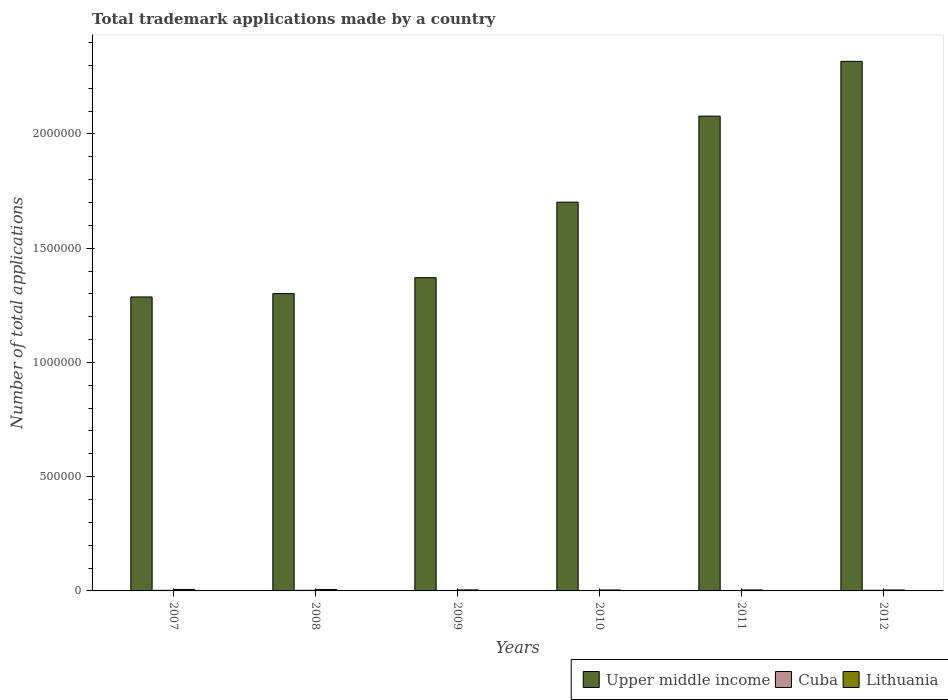How many different coloured bars are there?
Keep it short and to the point. 3. How many groups of bars are there?
Ensure brevity in your answer.  6. Are the number of bars on each tick of the X-axis equal?
Make the answer very short. Yes. In how many cases, is the number of bars for a given year not equal to the number of legend labels?
Keep it short and to the point. 0. What is the number of applications made by in Upper middle income in 2008?
Offer a very short reply. 1.30e+06. Across all years, what is the maximum number of applications made by in Lithuania?
Make the answer very short. 6440. Across all years, what is the minimum number of applications made by in Cuba?
Offer a terse response. 1389. In which year was the number of applications made by in Lithuania maximum?
Give a very brief answer. 2007. What is the total number of applications made by in Cuba in the graph?
Offer a very short reply. 1.32e+04. What is the difference between the number of applications made by in Lithuania in 2008 and that in 2012?
Provide a succinct answer. 2110. What is the difference between the number of applications made by in Upper middle income in 2007 and the number of applications made by in Cuba in 2008?
Offer a terse response. 1.28e+06. What is the average number of applications made by in Lithuania per year?
Provide a succinct answer. 5008. In the year 2010, what is the difference between the number of applications made by in Lithuania and number of applications made by in Upper middle income?
Ensure brevity in your answer.  -1.70e+06. In how many years, is the number of applications made by in Lithuania greater than 100000?
Your response must be concise. 0. What is the ratio of the number of applications made by in Lithuania in 2011 to that in 2012?
Make the answer very short. 1.02. Is the number of applications made by in Cuba in 2008 less than that in 2012?
Your response must be concise. Yes. Is the difference between the number of applications made by in Lithuania in 2008 and 2011 greater than the difference between the number of applications made by in Upper middle income in 2008 and 2011?
Provide a short and direct response. Yes. What is the difference between the highest and the second highest number of applications made by in Cuba?
Offer a terse response. 199. What is the difference between the highest and the lowest number of applications made by in Lithuania?
Offer a very short reply. 2218. In how many years, is the number of applications made by in Upper middle income greater than the average number of applications made by in Upper middle income taken over all years?
Provide a succinct answer. 3. What does the 3rd bar from the left in 2009 represents?
Ensure brevity in your answer.  Lithuania. What does the 1st bar from the right in 2007 represents?
Make the answer very short. Lithuania. How many bars are there?
Offer a terse response. 18. Are all the bars in the graph horizontal?
Offer a very short reply. No. What is the difference between two consecutive major ticks on the Y-axis?
Keep it short and to the point. 5.00e+05. Are the values on the major ticks of Y-axis written in scientific E-notation?
Ensure brevity in your answer.  No. Does the graph contain grids?
Make the answer very short. No. How many legend labels are there?
Your answer should be very brief. 3. How are the legend labels stacked?
Ensure brevity in your answer.  Horizontal. What is the title of the graph?
Give a very brief answer. Total trademark applications made by a country. What is the label or title of the X-axis?
Make the answer very short. Years. What is the label or title of the Y-axis?
Offer a terse response. Number of total applications. What is the Number of total applications of Upper middle income in 2007?
Provide a short and direct response. 1.29e+06. What is the Number of total applications in Cuba in 2007?
Ensure brevity in your answer.  2407. What is the Number of total applications of Lithuania in 2007?
Your answer should be very brief. 6440. What is the Number of total applications in Upper middle income in 2008?
Your answer should be very brief. 1.30e+06. What is the Number of total applications in Cuba in 2008?
Your response must be concise. 2540. What is the Number of total applications in Lithuania in 2008?
Your answer should be compact. 6332. What is the Number of total applications in Upper middle income in 2009?
Give a very brief answer. 1.37e+06. What is the Number of total applications in Cuba in 2009?
Keep it short and to the point. 2042. What is the Number of total applications in Lithuania in 2009?
Your response must be concise. 4465. What is the Number of total applications of Upper middle income in 2010?
Offer a terse response. 1.70e+06. What is the Number of total applications in Cuba in 2010?
Keep it short and to the point. 1389. What is the Number of total applications in Lithuania in 2010?
Your response must be concise. 4274. What is the Number of total applications of Upper middle income in 2011?
Provide a succinct answer. 2.08e+06. What is the Number of total applications in Cuba in 2011?
Give a very brief answer. 2041. What is the Number of total applications of Lithuania in 2011?
Your answer should be compact. 4315. What is the Number of total applications of Upper middle income in 2012?
Your answer should be compact. 2.32e+06. What is the Number of total applications in Cuba in 2012?
Keep it short and to the point. 2739. What is the Number of total applications of Lithuania in 2012?
Keep it short and to the point. 4222. Across all years, what is the maximum Number of total applications of Upper middle income?
Offer a terse response. 2.32e+06. Across all years, what is the maximum Number of total applications in Cuba?
Provide a short and direct response. 2739. Across all years, what is the maximum Number of total applications in Lithuania?
Your answer should be very brief. 6440. Across all years, what is the minimum Number of total applications of Upper middle income?
Ensure brevity in your answer.  1.29e+06. Across all years, what is the minimum Number of total applications in Cuba?
Provide a short and direct response. 1389. Across all years, what is the minimum Number of total applications of Lithuania?
Keep it short and to the point. 4222. What is the total Number of total applications in Upper middle income in the graph?
Your response must be concise. 1.01e+07. What is the total Number of total applications of Cuba in the graph?
Ensure brevity in your answer.  1.32e+04. What is the total Number of total applications in Lithuania in the graph?
Offer a very short reply. 3.00e+04. What is the difference between the Number of total applications in Upper middle income in 2007 and that in 2008?
Make the answer very short. -1.46e+04. What is the difference between the Number of total applications in Cuba in 2007 and that in 2008?
Provide a succinct answer. -133. What is the difference between the Number of total applications of Lithuania in 2007 and that in 2008?
Provide a short and direct response. 108. What is the difference between the Number of total applications of Upper middle income in 2007 and that in 2009?
Provide a succinct answer. -8.44e+04. What is the difference between the Number of total applications of Cuba in 2007 and that in 2009?
Ensure brevity in your answer.  365. What is the difference between the Number of total applications in Lithuania in 2007 and that in 2009?
Give a very brief answer. 1975. What is the difference between the Number of total applications in Upper middle income in 2007 and that in 2010?
Your answer should be very brief. -4.15e+05. What is the difference between the Number of total applications of Cuba in 2007 and that in 2010?
Give a very brief answer. 1018. What is the difference between the Number of total applications of Lithuania in 2007 and that in 2010?
Give a very brief answer. 2166. What is the difference between the Number of total applications of Upper middle income in 2007 and that in 2011?
Keep it short and to the point. -7.91e+05. What is the difference between the Number of total applications in Cuba in 2007 and that in 2011?
Your answer should be compact. 366. What is the difference between the Number of total applications of Lithuania in 2007 and that in 2011?
Provide a succinct answer. 2125. What is the difference between the Number of total applications in Upper middle income in 2007 and that in 2012?
Make the answer very short. -1.03e+06. What is the difference between the Number of total applications in Cuba in 2007 and that in 2012?
Provide a succinct answer. -332. What is the difference between the Number of total applications of Lithuania in 2007 and that in 2012?
Your answer should be very brief. 2218. What is the difference between the Number of total applications of Upper middle income in 2008 and that in 2009?
Your response must be concise. -6.98e+04. What is the difference between the Number of total applications in Cuba in 2008 and that in 2009?
Offer a very short reply. 498. What is the difference between the Number of total applications in Lithuania in 2008 and that in 2009?
Offer a very short reply. 1867. What is the difference between the Number of total applications of Upper middle income in 2008 and that in 2010?
Offer a very short reply. -4.00e+05. What is the difference between the Number of total applications of Cuba in 2008 and that in 2010?
Offer a very short reply. 1151. What is the difference between the Number of total applications of Lithuania in 2008 and that in 2010?
Your answer should be compact. 2058. What is the difference between the Number of total applications in Upper middle income in 2008 and that in 2011?
Your answer should be compact. -7.77e+05. What is the difference between the Number of total applications in Cuba in 2008 and that in 2011?
Your answer should be compact. 499. What is the difference between the Number of total applications in Lithuania in 2008 and that in 2011?
Your answer should be very brief. 2017. What is the difference between the Number of total applications in Upper middle income in 2008 and that in 2012?
Provide a short and direct response. -1.02e+06. What is the difference between the Number of total applications of Cuba in 2008 and that in 2012?
Your answer should be very brief. -199. What is the difference between the Number of total applications in Lithuania in 2008 and that in 2012?
Provide a short and direct response. 2110. What is the difference between the Number of total applications in Upper middle income in 2009 and that in 2010?
Your response must be concise. -3.30e+05. What is the difference between the Number of total applications of Cuba in 2009 and that in 2010?
Offer a terse response. 653. What is the difference between the Number of total applications of Lithuania in 2009 and that in 2010?
Your answer should be very brief. 191. What is the difference between the Number of total applications in Upper middle income in 2009 and that in 2011?
Provide a succinct answer. -7.07e+05. What is the difference between the Number of total applications of Cuba in 2009 and that in 2011?
Offer a terse response. 1. What is the difference between the Number of total applications of Lithuania in 2009 and that in 2011?
Your answer should be very brief. 150. What is the difference between the Number of total applications in Upper middle income in 2009 and that in 2012?
Offer a very short reply. -9.47e+05. What is the difference between the Number of total applications of Cuba in 2009 and that in 2012?
Provide a short and direct response. -697. What is the difference between the Number of total applications in Lithuania in 2009 and that in 2012?
Make the answer very short. 243. What is the difference between the Number of total applications in Upper middle income in 2010 and that in 2011?
Your response must be concise. -3.76e+05. What is the difference between the Number of total applications of Cuba in 2010 and that in 2011?
Your answer should be very brief. -652. What is the difference between the Number of total applications in Lithuania in 2010 and that in 2011?
Ensure brevity in your answer.  -41. What is the difference between the Number of total applications in Upper middle income in 2010 and that in 2012?
Provide a short and direct response. -6.16e+05. What is the difference between the Number of total applications in Cuba in 2010 and that in 2012?
Provide a succinct answer. -1350. What is the difference between the Number of total applications in Upper middle income in 2011 and that in 2012?
Your answer should be very brief. -2.40e+05. What is the difference between the Number of total applications in Cuba in 2011 and that in 2012?
Make the answer very short. -698. What is the difference between the Number of total applications of Lithuania in 2011 and that in 2012?
Offer a very short reply. 93. What is the difference between the Number of total applications in Upper middle income in 2007 and the Number of total applications in Cuba in 2008?
Give a very brief answer. 1.28e+06. What is the difference between the Number of total applications in Upper middle income in 2007 and the Number of total applications in Lithuania in 2008?
Your response must be concise. 1.28e+06. What is the difference between the Number of total applications of Cuba in 2007 and the Number of total applications of Lithuania in 2008?
Keep it short and to the point. -3925. What is the difference between the Number of total applications of Upper middle income in 2007 and the Number of total applications of Cuba in 2009?
Your answer should be compact. 1.28e+06. What is the difference between the Number of total applications in Upper middle income in 2007 and the Number of total applications in Lithuania in 2009?
Offer a very short reply. 1.28e+06. What is the difference between the Number of total applications of Cuba in 2007 and the Number of total applications of Lithuania in 2009?
Provide a short and direct response. -2058. What is the difference between the Number of total applications of Upper middle income in 2007 and the Number of total applications of Cuba in 2010?
Keep it short and to the point. 1.29e+06. What is the difference between the Number of total applications of Upper middle income in 2007 and the Number of total applications of Lithuania in 2010?
Provide a short and direct response. 1.28e+06. What is the difference between the Number of total applications in Cuba in 2007 and the Number of total applications in Lithuania in 2010?
Your response must be concise. -1867. What is the difference between the Number of total applications in Upper middle income in 2007 and the Number of total applications in Cuba in 2011?
Offer a terse response. 1.28e+06. What is the difference between the Number of total applications in Upper middle income in 2007 and the Number of total applications in Lithuania in 2011?
Make the answer very short. 1.28e+06. What is the difference between the Number of total applications of Cuba in 2007 and the Number of total applications of Lithuania in 2011?
Offer a very short reply. -1908. What is the difference between the Number of total applications in Upper middle income in 2007 and the Number of total applications in Cuba in 2012?
Keep it short and to the point. 1.28e+06. What is the difference between the Number of total applications in Upper middle income in 2007 and the Number of total applications in Lithuania in 2012?
Keep it short and to the point. 1.28e+06. What is the difference between the Number of total applications of Cuba in 2007 and the Number of total applications of Lithuania in 2012?
Keep it short and to the point. -1815. What is the difference between the Number of total applications in Upper middle income in 2008 and the Number of total applications in Cuba in 2009?
Provide a succinct answer. 1.30e+06. What is the difference between the Number of total applications of Upper middle income in 2008 and the Number of total applications of Lithuania in 2009?
Your answer should be very brief. 1.30e+06. What is the difference between the Number of total applications of Cuba in 2008 and the Number of total applications of Lithuania in 2009?
Your response must be concise. -1925. What is the difference between the Number of total applications of Upper middle income in 2008 and the Number of total applications of Cuba in 2010?
Provide a succinct answer. 1.30e+06. What is the difference between the Number of total applications of Upper middle income in 2008 and the Number of total applications of Lithuania in 2010?
Ensure brevity in your answer.  1.30e+06. What is the difference between the Number of total applications of Cuba in 2008 and the Number of total applications of Lithuania in 2010?
Offer a terse response. -1734. What is the difference between the Number of total applications in Upper middle income in 2008 and the Number of total applications in Cuba in 2011?
Provide a succinct answer. 1.30e+06. What is the difference between the Number of total applications of Upper middle income in 2008 and the Number of total applications of Lithuania in 2011?
Offer a very short reply. 1.30e+06. What is the difference between the Number of total applications in Cuba in 2008 and the Number of total applications in Lithuania in 2011?
Give a very brief answer. -1775. What is the difference between the Number of total applications in Upper middle income in 2008 and the Number of total applications in Cuba in 2012?
Offer a terse response. 1.30e+06. What is the difference between the Number of total applications of Upper middle income in 2008 and the Number of total applications of Lithuania in 2012?
Offer a very short reply. 1.30e+06. What is the difference between the Number of total applications in Cuba in 2008 and the Number of total applications in Lithuania in 2012?
Provide a succinct answer. -1682. What is the difference between the Number of total applications of Upper middle income in 2009 and the Number of total applications of Cuba in 2010?
Provide a short and direct response. 1.37e+06. What is the difference between the Number of total applications in Upper middle income in 2009 and the Number of total applications in Lithuania in 2010?
Provide a short and direct response. 1.37e+06. What is the difference between the Number of total applications of Cuba in 2009 and the Number of total applications of Lithuania in 2010?
Offer a very short reply. -2232. What is the difference between the Number of total applications in Upper middle income in 2009 and the Number of total applications in Cuba in 2011?
Make the answer very short. 1.37e+06. What is the difference between the Number of total applications of Upper middle income in 2009 and the Number of total applications of Lithuania in 2011?
Your answer should be very brief. 1.37e+06. What is the difference between the Number of total applications in Cuba in 2009 and the Number of total applications in Lithuania in 2011?
Your response must be concise. -2273. What is the difference between the Number of total applications of Upper middle income in 2009 and the Number of total applications of Cuba in 2012?
Your answer should be compact. 1.37e+06. What is the difference between the Number of total applications of Upper middle income in 2009 and the Number of total applications of Lithuania in 2012?
Keep it short and to the point. 1.37e+06. What is the difference between the Number of total applications of Cuba in 2009 and the Number of total applications of Lithuania in 2012?
Offer a very short reply. -2180. What is the difference between the Number of total applications of Upper middle income in 2010 and the Number of total applications of Cuba in 2011?
Provide a succinct answer. 1.70e+06. What is the difference between the Number of total applications in Upper middle income in 2010 and the Number of total applications in Lithuania in 2011?
Your answer should be compact. 1.70e+06. What is the difference between the Number of total applications of Cuba in 2010 and the Number of total applications of Lithuania in 2011?
Provide a short and direct response. -2926. What is the difference between the Number of total applications of Upper middle income in 2010 and the Number of total applications of Cuba in 2012?
Provide a short and direct response. 1.70e+06. What is the difference between the Number of total applications in Upper middle income in 2010 and the Number of total applications in Lithuania in 2012?
Your answer should be compact. 1.70e+06. What is the difference between the Number of total applications of Cuba in 2010 and the Number of total applications of Lithuania in 2012?
Ensure brevity in your answer.  -2833. What is the difference between the Number of total applications in Upper middle income in 2011 and the Number of total applications in Cuba in 2012?
Keep it short and to the point. 2.07e+06. What is the difference between the Number of total applications of Upper middle income in 2011 and the Number of total applications of Lithuania in 2012?
Ensure brevity in your answer.  2.07e+06. What is the difference between the Number of total applications of Cuba in 2011 and the Number of total applications of Lithuania in 2012?
Offer a very short reply. -2181. What is the average Number of total applications of Upper middle income per year?
Your answer should be very brief. 1.68e+06. What is the average Number of total applications in Cuba per year?
Give a very brief answer. 2193. What is the average Number of total applications of Lithuania per year?
Keep it short and to the point. 5008. In the year 2007, what is the difference between the Number of total applications in Upper middle income and Number of total applications in Cuba?
Give a very brief answer. 1.28e+06. In the year 2007, what is the difference between the Number of total applications in Upper middle income and Number of total applications in Lithuania?
Keep it short and to the point. 1.28e+06. In the year 2007, what is the difference between the Number of total applications of Cuba and Number of total applications of Lithuania?
Give a very brief answer. -4033. In the year 2008, what is the difference between the Number of total applications of Upper middle income and Number of total applications of Cuba?
Ensure brevity in your answer.  1.30e+06. In the year 2008, what is the difference between the Number of total applications of Upper middle income and Number of total applications of Lithuania?
Provide a succinct answer. 1.29e+06. In the year 2008, what is the difference between the Number of total applications in Cuba and Number of total applications in Lithuania?
Ensure brevity in your answer.  -3792. In the year 2009, what is the difference between the Number of total applications of Upper middle income and Number of total applications of Cuba?
Keep it short and to the point. 1.37e+06. In the year 2009, what is the difference between the Number of total applications of Upper middle income and Number of total applications of Lithuania?
Provide a succinct answer. 1.37e+06. In the year 2009, what is the difference between the Number of total applications in Cuba and Number of total applications in Lithuania?
Your answer should be very brief. -2423. In the year 2010, what is the difference between the Number of total applications of Upper middle income and Number of total applications of Cuba?
Ensure brevity in your answer.  1.70e+06. In the year 2010, what is the difference between the Number of total applications of Upper middle income and Number of total applications of Lithuania?
Give a very brief answer. 1.70e+06. In the year 2010, what is the difference between the Number of total applications of Cuba and Number of total applications of Lithuania?
Your answer should be compact. -2885. In the year 2011, what is the difference between the Number of total applications of Upper middle income and Number of total applications of Cuba?
Keep it short and to the point. 2.08e+06. In the year 2011, what is the difference between the Number of total applications of Upper middle income and Number of total applications of Lithuania?
Keep it short and to the point. 2.07e+06. In the year 2011, what is the difference between the Number of total applications of Cuba and Number of total applications of Lithuania?
Ensure brevity in your answer.  -2274. In the year 2012, what is the difference between the Number of total applications of Upper middle income and Number of total applications of Cuba?
Offer a very short reply. 2.31e+06. In the year 2012, what is the difference between the Number of total applications in Upper middle income and Number of total applications in Lithuania?
Keep it short and to the point. 2.31e+06. In the year 2012, what is the difference between the Number of total applications in Cuba and Number of total applications in Lithuania?
Offer a terse response. -1483. What is the ratio of the Number of total applications of Cuba in 2007 to that in 2008?
Your answer should be very brief. 0.95. What is the ratio of the Number of total applications of Lithuania in 2007 to that in 2008?
Provide a succinct answer. 1.02. What is the ratio of the Number of total applications in Upper middle income in 2007 to that in 2009?
Offer a very short reply. 0.94. What is the ratio of the Number of total applications of Cuba in 2007 to that in 2009?
Offer a very short reply. 1.18. What is the ratio of the Number of total applications in Lithuania in 2007 to that in 2009?
Provide a short and direct response. 1.44. What is the ratio of the Number of total applications in Upper middle income in 2007 to that in 2010?
Offer a terse response. 0.76. What is the ratio of the Number of total applications in Cuba in 2007 to that in 2010?
Offer a very short reply. 1.73. What is the ratio of the Number of total applications of Lithuania in 2007 to that in 2010?
Provide a succinct answer. 1.51. What is the ratio of the Number of total applications in Upper middle income in 2007 to that in 2011?
Your answer should be very brief. 0.62. What is the ratio of the Number of total applications in Cuba in 2007 to that in 2011?
Your answer should be very brief. 1.18. What is the ratio of the Number of total applications in Lithuania in 2007 to that in 2011?
Give a very brief answer. 1.49. What is the ratio of the Number of total applications of Upper middle income in 2007 to that in 2012?
Give a very brief answer. 0.56. What is the ratio of the Number of total applications in Cuba in 2007 to that in 2012?
Give a very brief answer. 0.88. What is the ratio of the Number of total applications in Lithuania in 2007 to that in 2012?
Ensure brevity in your answer.  1.53. What is the ratio of the Number of total applications of Upper middle income in 2008 to that in 2009?
Make the answer very short. 0.95. What is the ratio of the Number of total applications of Cuba in 2008 to that in 2009?
Ensure brevity in your answer.  1.24. What is the ratio of the Number of total applications of Lithuania in 2008 to that in 2009?
Your response must be concise. 1.42. What is the ratio of the Number of total applications in Upper middle income in 2008 to that in 2010?
Offer a terse response. 0.76. What is the ratio of the Number of total applications in Cuba in 2008 to that in 2010?
Keep it short and to the point. 1.83. What is the ratio of the Number of total applications of Lithuania in 2008 to that in 2010?
Make the answer very short. 1.48. What is the ratio of the Number of total applications in Upper middle income in 2008 to that in 2011?
Offer a terse response. 0.63. What is the ratio of the Number of total applications of Cuba in 2008 to that in 2011?
Give a very brief answer. 1.24. What is the ratio of the Number of total applications in Lithuania in 2008 to that in 2011?
Give a very brief answer. 1.47. What is the ratio of the Number of total applications in Upper middle income in 2008 to that in 2012?
Your answer should be compact. 0.56. What is the ratio of the Number of total applications of Cuba in 2008 to that in 2012?
Offer a very short reply. 0.93. What is the ratio of the Number of total applications of Lithuania in 2008 to that in 2012?
Ensure brevity in your answer.  1.5. What is the ratio of the Number of total applications in Upper middle income in 2009 to that in 2010?
Provide a succinct answer. 0.81. What is the ratio of the Number of total applications in Cuba in 2009 to that in 2010?
Ensure brevity in your answer.  1.47. What is the ratio of the Number of total applications of Lithuania in 2009 to that in 2010?
Ensure brevity in your answer.  1.04. What is the ratio of the Number of total applications of Upper middle income in 2009 to that in 2011?
Provide a succinct answer. 0.66. What is the ratio of the Number of total applications in Lithuania in 2009 to that in 2011?
Your response must be concise. 1.03. What is the ratio of the Number of total applications of Upper middle income in 2009 to that in 2012?
Give a very brief answer. 0.59. What is the ratio of the Number of total applications in Cuba in 2009 to that in 2012?
Keep it short and to the point. 0.75. What is the ratio of the Number of total applications of Lithuania in 2009 to that in 2012?
Give a very brief answer. 1.06. What is the ratio of the Number of total applications of Upper middle income in 2010 to that in 2011?
Make the answer very short. 0.82. What is the ratio of the Number of total applications of Cuba in 2010 to that in 2011?
Offer a terse response. 0.68. What is the ratio of the Number of total applications in Lithuania in 2010 to that in 2011?
Offer a terse response. 0.99. What is the ratio of the Number of total applications of Upper middle income in 2010 to that in 2012?
Give a very brief answer. 0.73. What is the ratio of the Number of total applications of Cuba in 2010 to that in 2012?
Keep it short and to the point. 0.51. What is the ratio of the Number of total applications of Lithuania in 2010 to that in 2012?
Provide a short and direct response. 1.01. What is the ratio of the Number of total applications in Upper middle income in 2011 to that in 2012?
Keep it short and to the point. 0.9. What is the ratio of the Number of total applications in Cuba in 2011 to that in 2012?
Provide a succinct answer. 0.75. What is the ratio of the Number of total applications in Lithuania in 2011 to that in 2012?
Your response must be concise. 1.02. What is the difference between the highest and the second highest Number of total applications in Upper middle income?
Your response must be concise. 2.40e+05. What is the difference between the highest and the second highest Number of total applications in Cuba?
Ensure brevity in your answer.  199. What is the difference between the highest and the second highest Number of total applications of Lithuania?
Your response must be concise. 108. What is the difference between the highest and the lowest Number of total applications in Upper middle income?
Your answer should be very brief. 1.03e+06. What is the difference between the highest and the lowest Number of total applications in Cuba?
Your answer should be very brief. 1350. What is the difference between the highest and the lowest Number of total applications in Lithuania?
Offer a very short reply. 2218. 